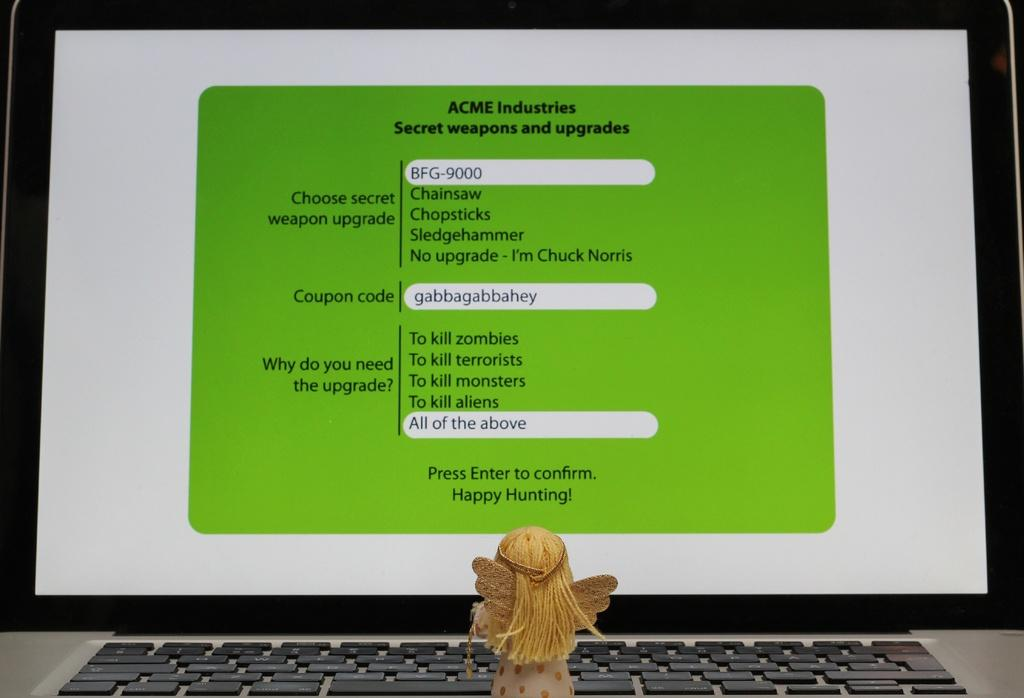Provide a one-sentence caption for the provided image. If you require secret weapons and upgrades, then ACME Industries is the place to get them. 